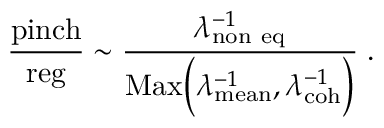<formula> <loc_0><loc_0><loc_500><loc_500>{ \frac { p i n c h } { r e g } } \sim { \frac { \lambda _ { n o n \ e q } ^ { - 1 } } { M a x \left ( \lambda _ { m e a n } ^ { - 1 } , \lambda _ { c o h } ^ { - 1 } \right ) } } \, .</formula> 